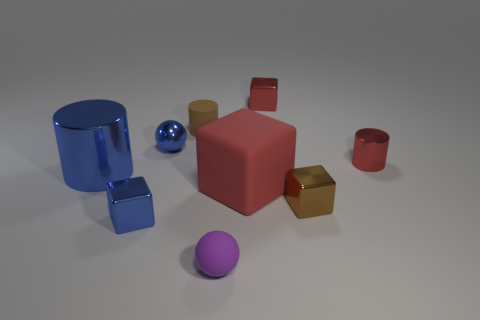Subtract 1 blocks. How many blocks are left? 3 Subtract all blocks. How many objects are left? 5 Add 4 small matte cylinders. How many small matte cylinders are left? 5 Add 1 brown cubes. How many brown cubes exist? 2 Subtract 1 blue cubes. How many objects are left? 8 Subtract all large things. Subtract all small red metal objects. How many objects are left? 5 